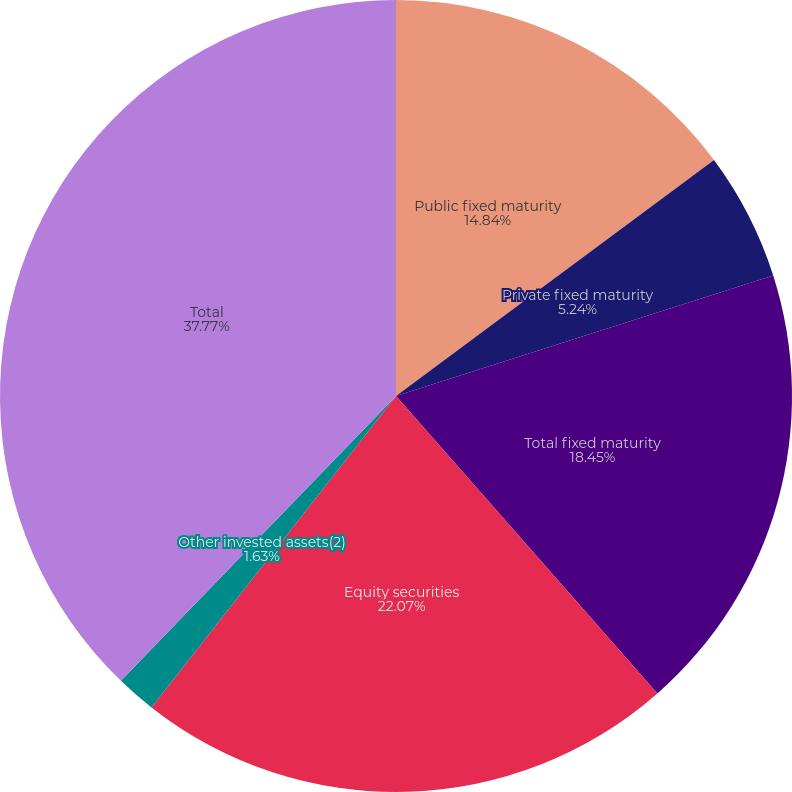Convert chart to OTSL. <chart><loc_0><loc_0><loc_500><loc_500><pie_chart><fcel>Public fixed maturity<fcel>Private fixed maturity<fcel>Total fixed maturity<fcel>Equity securities<fcel>Other invested assets(2)<fcel>Total<nl><fcel>14.84%<fcel>5.24%<fcel>18.45%<fcel>22.07%<fcel>1.63%<fcel>37.78%<nl></chart> 